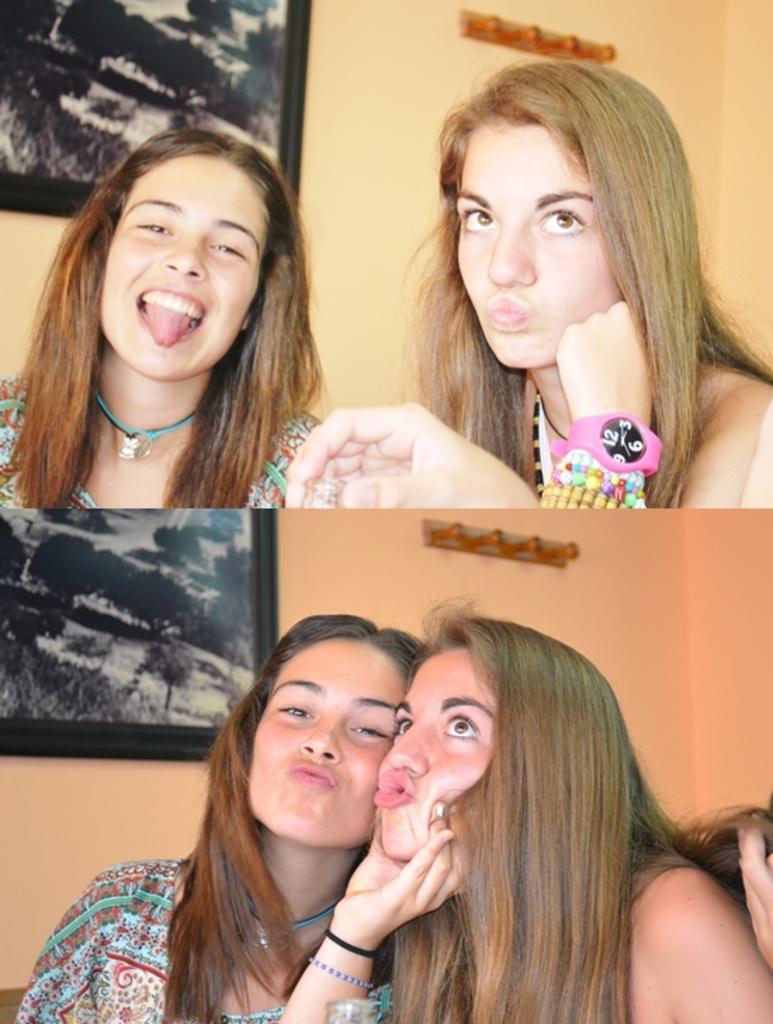Describe this image in one or two sentences. In this image we can see two women. Here we can see a woman on the left side and she is smiling. Here we can see the photo frame on the wall. 